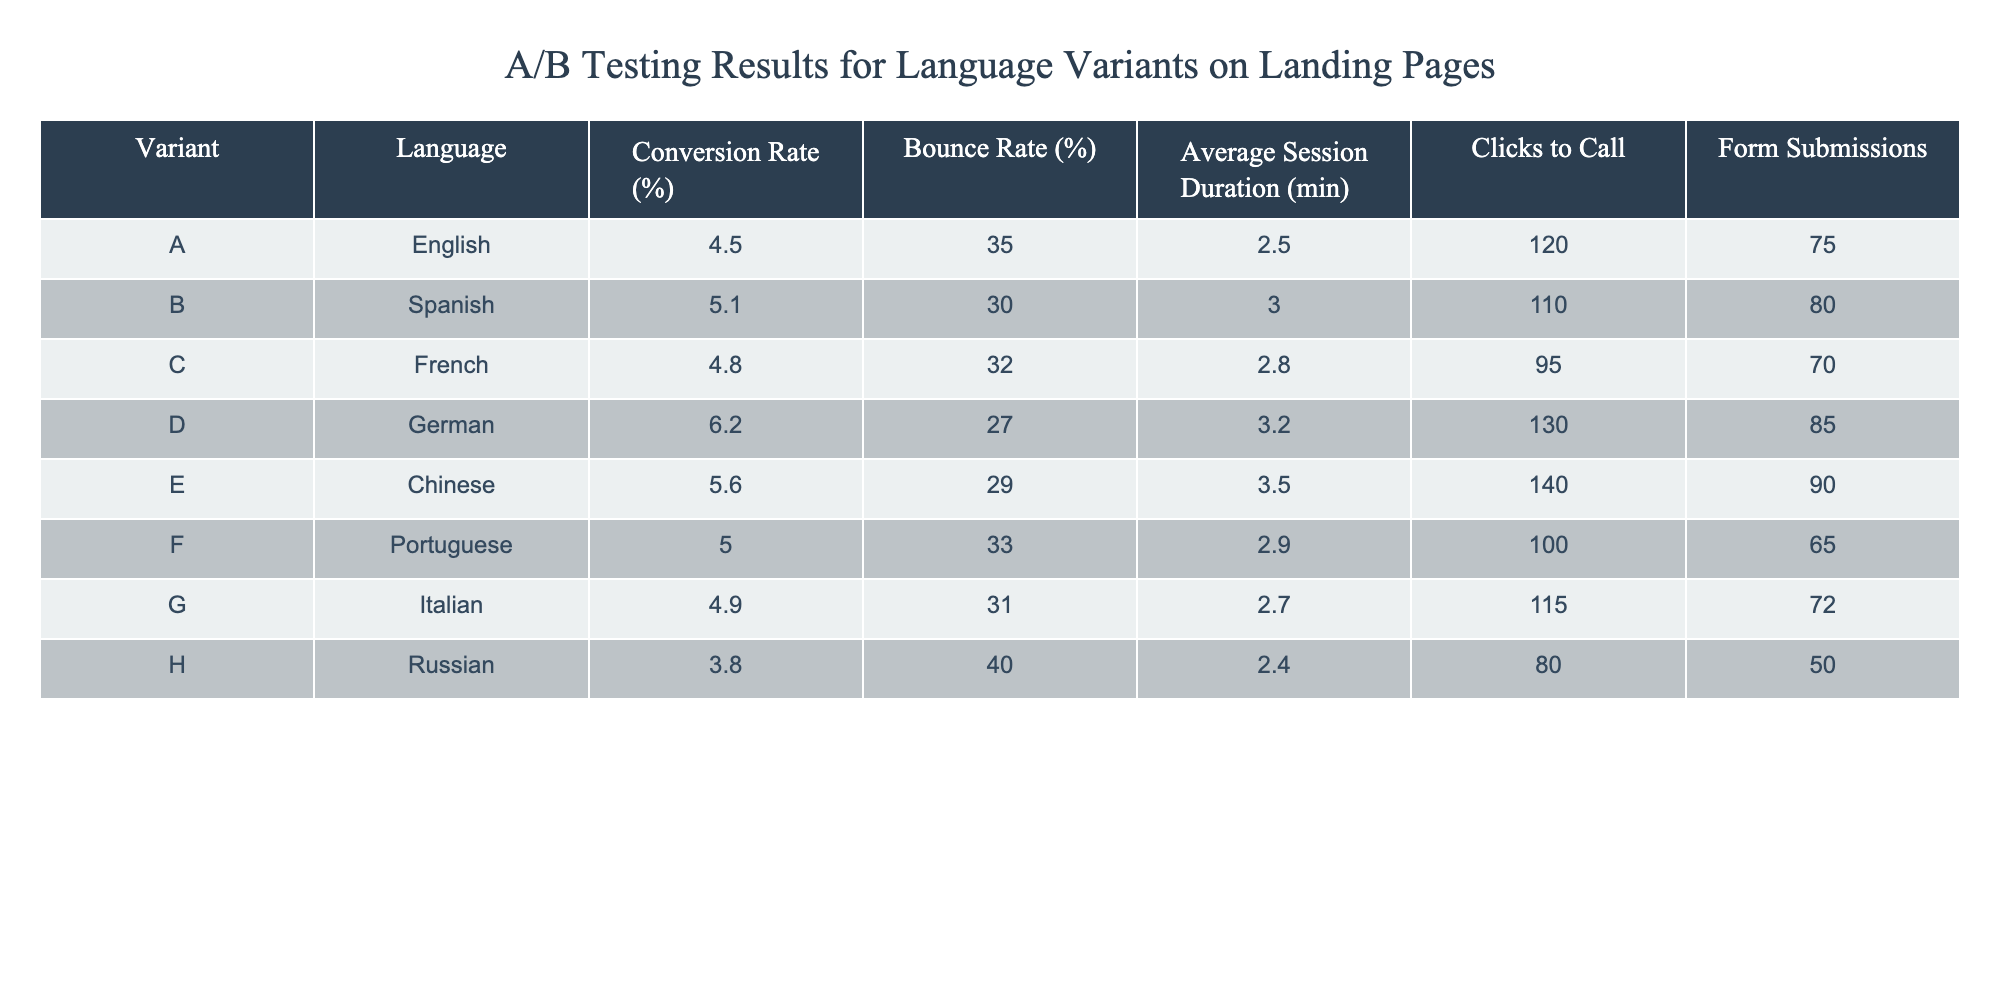What is the conversion rate for the German variant? The table lists the conversion rates for each variant, and for the German variant (D), the conversion rate is specified as 6.2%.
Answer: 6.2% Which language variant had the highest bounce rate? The table shows the bounce rates for each language variant, and the Russian variant (H) has the highest bounce rate at 40%.
Answer: 40% What is the average session duration for the Spanish and French variants combined? The average session durations for Spanish (3.0 minutes) and French (2.8 minutes) can be calculated by averaging the two: (3.0 + 2.8) / 2 = 2.9 minutes.
Answer: 2.9 Did the English variant have a higher conversion rate than the Italian variant? The English variant (A) has a conversion rate of 4.5%, and the Italian variant (G) has a conversion rate of 4.9%. Since 4.5% is less than 4.9%, the English variant did not have a higher conversion rate.
Answer: No What is the total number of clicks to call across all variants? Adding the clicks to call for each variant: 120 (A) + 110 (B) + 95 (C) + 130 (D) + 140 (E) + 100 (F) + 115 (G) + 80 (H) = 1,000.
Answer: 1000 Which language variant had the most form submissions? The table shows form submissions for each variant. The Chinese variant (E) has the most form submissions at 90.
Answer: 90 What is the difference in conversion rates between the German and Russian variants? The conversion rate for the German variant (D) is 6.2%, and for the Russian variant (H) it is 3.8%. The difference is 6.2 - 3.8 = 2.4%.
Answer: 2.4 Is the average session duration for the Chinese variant longer than that for the Portuguese variant? The session duration for the Chinese variant (E) is 3.5 minutes, while for the Portuguese variant (F), it is 2.9 minutes. Since 3.5 is greater than 2.9, the Chinese variant has a longer average session duration.
Answer: Yes 